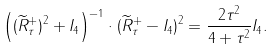<formula> <loc_0><loc_0><loc_500><loc_500>\left ( ( \widetilde { R } ^ { + } _ { \tau } ) ^ { 2 } + I _ { 4 } \right ) ^ { - 1 } \cdot ( \widetilde { R } ^ { + } _ { \tau } - I _ { 4 } ) ^ { 2 } = \frac { 2 \tau ^ { 2 } } { 4 + \tau ^ { 2 } } I _ { 4 } .</formula> 